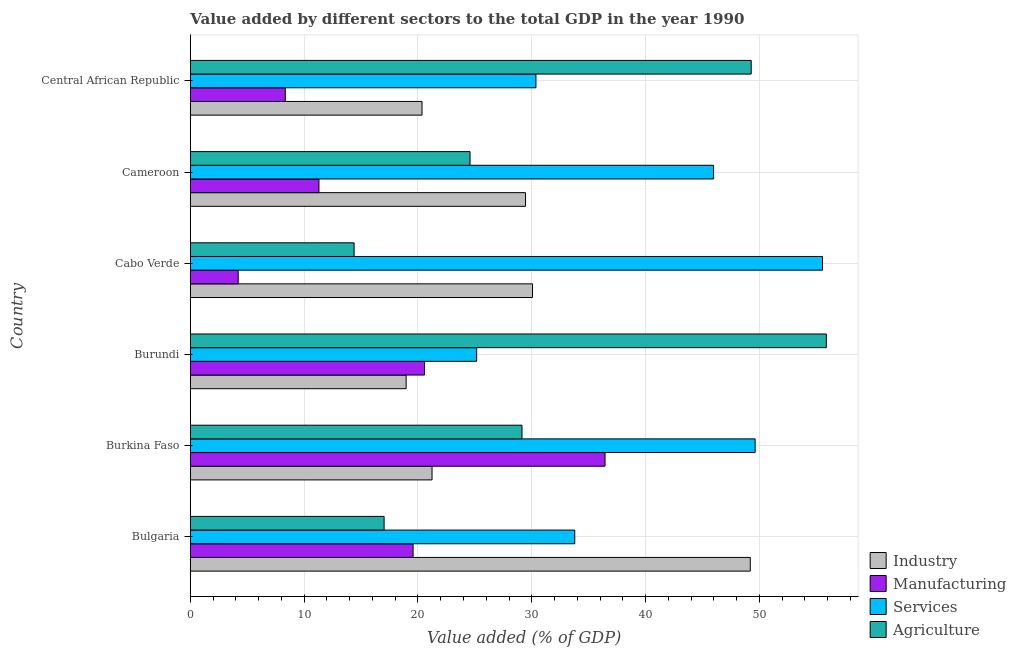How many groups of bars are there?
Offer a terse response. 6. Are the number of bars per tick equal to the number of legend labels?
Provide a short and direct response. Yes. How many bars are there on the 5th tick from the bottom?
Keep it short and to the point. 4. What is the label of the 4th group of bars from the top?
Provide a short and direct response. Burundi. In how many cases, is the number of bars for a given country not equal to the number of legend labels?
Provide a short and direct response. 0. What is the value added by agricultural sector in Bulgaria?
Your answer should be very brief. 17.03. Across all countries, what is the maximum value added by manufacturing sector?
Make the answer very short. 36.44. Across all countries, what is the minimum value added by manufacturing sector?
Your response must be concise. 4.21. In which country was the value added by industrial sector maximum?
Offer a very short reply. Bulgaria. In which country was the value added by agricultural sector minimum?
Your answer should be compact. Cabo Verde. What is the total value added by industrial sector in the graph?
Make the answer very short. 169.27. What is the difference between the value added by manufacturing sector in Burkina Faso and that in Central African Republic?
Ensure brevity in your answer.  28.09. What is the difference between the value added by agricultural sector in Cameroon and the value added by manufacturing sector in Burkina Faso?
Your answer should be very brief. -11.86. What is the average value added by agricultural sector per country?
Offer a terse response. 31.71. What is the difference between the value added by industrial sector and value added by manufacturing sector in Bulgaria?
Provide a succinct answer. 29.62. What is the ratio of the value added by agricultural sector in Burundi to that in Cameroon?
Your answer should be compact. 2.27. What is the difference between the highest and the second highest value added by services sector?
Provide a short and direct response. 5.92. What is the difference between the highest and the lowest value added by agricultural sector?
Offer a very short reply. 41.49. In how many countries, is the value added by manufacturing sector greater than the average value added by manufacturing sector taken over all countries?
Offer a terse response. 3. Is the sum of the value added by industrial sector in Cabo Verde and Central African Republic greater than the maximum value added by manufacturing sector across all countries?
Keep it short and to the point. Yes. What does the 1st bar from the top in Central African Republic represents?
Provide a succinct answer. Agriculture. What does the 1st bar from the bottom in Bulgaria represents?
Your response must be concise. Industry. Is it the case that in every country, the sum of the value added by industrial sector and value added by manufacturing sector is greater than the value added by services sector?
Your answer should be compact. No. Are all the bars in the graph horizontal?
Provide a short and direct response. Yes. How many countries are there in the graph?
Give a very brief answer. 6. How are the legend labels stacked?
Your answer should be compact. Vertical. What is the title of the graph?
Keep it short and to the point. Value added by different sectors to the total GDP in the year 1990. What is the label or title of the X-axis?
Provide a succinct answer. Value added (% of GDP). What is the label or title of the Y-axis?
Provide a succinct answer. Country. What is the Value added (% of GDP) in Industry in Bulgaria?
Your response must be concise. 49.2. What is the Value added (% of GDP) of Manufacturing in Bulgaria?
Provide a succinct answer. 19.57. What is the Value added (% of GDP) in Services in Bulgaria?
Provide a short and direct response. 33.78. What is the Value added (% of GDP) of Agriculture in Bulgaria?
Offer a very short reply. 17.03. What is the Value added (% of GDP) in Industry in Burkina Faso?
Make the answer very short. 21.24. What is the Value added (% of GDP) in Manufacturing in Burkina Faso?
Offer a terse response. 36.44. What is the Value added (% of GDP) in Services in Burkina Faso?
Keep it short and to the point. 49.62. What is the Value added (% of GDP) in Agriculture in Burkina Faso?
Your response must be concise. 29.14. What is the Value added (% of GDP) in Industry in Burundi?
Offer a very short reply. 18.96. What is the Value added (% of GDP) in Manufacturing in Burundi?
Your answer should be compact. 20.58. What is the Value added (% of GDP) in Services in Burundi?
Provide a succinct answer. 25.16. What is the Value added (% of GDP) in Agriculture in Burundi?
Your answer should be compact. 55.88. What is the Value added (% of GDP) in Industry in Cabo Verde?
Make the answer very short. 30.07. What is the Value added (% of GDP) of Manufacturing in Cabo Verde?
Your response must be concise. 4.21. What is the Value added (% of GDP) in Services in Cabo Verde?
Make the answer very short. 55.54. What is the Value added (% of GDP) in Agriculture in Cabo Verde?
Your answer should be compact. 14.39. What is the Value added (% of GDP) of Industry in Cameroon?
Provide a short and direct response. 29.45. What is the Value added (% of GDP) in Manufacturing in Cameroon?
Your response must be concise. 11.3. What is the Value added (% of GDP) in Services in Cameroon?
Offer a terse response. 45.97. What is the Value added (% of GDP) of Agriculture in Cameroon?
Ensure brevity in your answer.  24.58. What is the Value added (% of GDP) in Industry in Central African Republic?
Provide a succinct answer. 20.36. What is the Value added (% of GDP) in Manufacturing in Central African Republic?
Offer a terse response. 8.35. What is the Value added (% of GDP) in Services in Central African Republic?
Offer a terse response. 30.37. What is the Value added (% of GDP) in Agriculture in Central African Republic?
Offer a very short reply. 49.28. Across all countries, what is the maximum Value added (% of GDP) in Industry?
Provide a succinct answer. 49.2. Across all countries, what is the maximum Value added (% of GDP) of Manufacturing?
Your answer should be compact. 36.44. Across all countries, what is the maximum Value added (% of GDP) in Services?
Ensure brevity in your answer.  55.54. Across all countries, what is the maximum Value added (% of GDP) of Agriculture?
Make the answer very short. 55.88. Across all countries, what is the minimum Value added (% of GDP) of Industry?
Provide a short and direct response. 18.96. Across all countries, what is the minimum Value added (% of GDP) in Manufacturing?
Your answer should be compact. 4.21. Across all countries, what is the minimum Value added (% of GDP) in Services?
Your answer should be very brief. 25.16. Across all countries, what is the minimum Value added (% of GDP) of Agriculture?
Give a very brief answer. 14.39. What is the total Value added (% of GDP) in Industry in the graph?
Give a very brief answer. 169.27. What is the total Value added (% of GDP) in Manufacturing in the graph?
Your response must be concise. 100.45. What is the total Value added (% of GDP) of Services in the graph?
Your answer should be compact. 240.44. What is the total Value added (% of GDP) of Agriculture in the graph?
Your answer should be compact. 190.29. What is the difference between the Value added (% of GDP) in Industry in Bulgaria and that in Burkina Faso?
Your answer should be very brief. 27.96. What is the difference between the Value added (% of GDP) of Manufacturing in Bulgaria and that in Burkina Faso?
Ensure brevity in your answer.  -16.86. What is the difference between the Value added (% of GDP) in Services in Bulgaria and that in Burkina Faso?
Your answer should be compact. -15.84. What is the difference between the Value added (% of GDP) in Agriculture in Bulgaria and that in Burkina Faso?
Ensure brevity in your answer.  -12.11. What is the difference between the Value added (% of GDP) in Industry in Bulgaria and that in Burundi?
Your answer should be compact. 30.23. What is the difference between the Value added (% of GDP) of Manufacturing in Bulgaria and that in Burundi?
Give a very brief answer. -1.01. What is the difference between the Value added (% of GDP) in Services in Bulgaria and that in Burundi?
Your response must be concise. 8.62. What is the difference between the Value added (% of GDP) in Agriculture in Bulgaria and that in Burundi?
Provide a succinct answer. -38.85. What is the difference between the Value added (% of GDP) in Industry in Bulgaria and that in Cabo Verde?
Offer a terse response. 19.13. What is the difference between the Value added (% of GDP) of Manufacturing in Bulgaria and that in Cabo Verde?
Give a very brief answer. 15.36. What is the difference between the Value added (% of GDP) of Services in Bulgaria and that in Cabo Verde?
Provide a succinct answer. -21.77. What is the difference between the Value added (% of GDP) of Agriculture in Bulgaria and that in Cabo Verde?
Keep it short and to the point. 2.64. What is the difference between the Value added (% of GDP) in Industry in Bulgaria and that in Cameroon?
Ensure brevity in your answer.  19.75. What is the difference between the Value added (% of GDP) in Manufacturing in Bulgaria and that in Cameroon?
Your answer should be very brief. 8.27. What is the difference between the Value added (% of GDP) in Services in Bulgaria and that in Cameroon?
Provide a succinct answer. -12.2. What is the difference between the Value added (% of GDP) in Agriculture in Bulgaria and that in Cameroon?
Provide a short and direct response. -7.55. What is the difference between the Value added (% of GDP) of Industry in Bulgaria and that in Central African Republic?
Provide a succinct answer. 28.84. What is the difference between the Value added (% of GDP) of Manufacturing in Bulgaria and that in Central African Republic?
Keep it short and to the point. 11.23. What is the difference between the Value added (% of GDP) in Services in Bulgaria and that in Central African Republic?
Provide a succinct answer. 3.41. What is the difference between the Value added (% of GDP) of Agriculture in Bulgaria and that in Central African Republic?
Your answer should be very brief. -32.25. What is the difference between the Value added (% of GDP) in Industry in Burkina Faso and that in Burundi?
Your answer should be very brief. 2.27. What is the difference between the Value added (% of GDP) of Manufacturing in Burkina Faso and that in Burundi?
Your response must be concise. 15.86. What is the difference between the Value added (% of GDP) in Services in Burkina Faso and that in Burundi?
Make the answer very short. 24.46. What is the difference between the Value added (% of GDP) in Agriculture in Burkina Faso and that in Burundi?
Ensure brevity in your answer.  -26.74. What is the difference between the Value added (% of GDP) of Industry in Burkina Faso and that in Cabo Verde?
Make the answer very short. -8.83. What is the difference between the Value added (% of GDP) of Manufacturing in Burkina Faso and that in Cabo Verde?
Offer a very short reply. 32.23. What is the difference between the Value added (% of GDP) of Services in Burkina Faso and that in Cabo Verde?
Your answer should be very brief. -5.92. What is the difference between the Value added (% of GDP) of Agriculture in Burkina Faso and that in Cabo Verde?
Offer a terse response. 14.75. What is the difference between the Value added (% of GDP) in Industry in Burkina Faso and that in Cameroon?
Keep it short and to the point. -8.21. What is the difference between the Value added (% of GDP) in Manufacturing in Burkina Faso and that in Cameroon?
Provide a succinct answer. 25.13. What is the difference between the Value added (% of GDP) in Services in Burkina Faso and that in Cameroon?
Your response must be concise. 3.65. What is the difference between the Value added (% of GDP) of Agriculture in Burkina Faso and that in Cameroon?
Ensure brevity in your answer.  4.57. What is the difference between the Value added (% of GDP) of Industry in Burkina Faso and that in Central African Republic?
Provide a succinct answer. 0.88. What is the difference between the Value added (% of GDP) of Manufacturing in Burkina Faso and that in Central African Republic?
Your answer should be compact. 28.09. What is the difference between the Value added (% of GDP) in Services in Burkina Faso and that in Central African Republic?
Keep it short and to the point. 19.26. What is the difference between the Value added (% of GDP) in Agriculture in Burkina Faso and that in Central African Republic?
Provide a short and direct response. -20.13. What is the difference between the Value added (% of GDP) in Industry in Burundi and that in Cabo Verde?
Keep it short and to the point. -11.1. What is the difference between the Value added (% of GDP) of Manufacturing in Burundi and that in Cabo Verde?
Provide a short and direct response. 16.37. What is the difference between the Value added (% of GDP) in Services in Burundi and that in Cabo Verde?
Offer a terse response. -30.39. What is the difference between the Value added (% of GDP) in Agriculture in Burundi and that in Cabo Verde?
Your answer should be compact. 41.49. What is the difference between the Value added (% of GDP) in Industry in Burundi and that in Cameroon?
Your answer should be compact. -10.49. What is the difference between the Value added (% of GDP) of Manufacturing in Burundi and that in Cameroon?
Keep it short and to the point. 9.28. What is the difference between the Value added (% of GDP) in Services in Burundi and that in Cameroon?
Make the answer very short. -20.82. What is the difference between the Value added (% of GDP) of Agriculture in Burundi and that in Cameroon?
Provide a succinct answer. 31.3. What is the difference between the Value added (% of GDP) of Industry in Burundi and that in Central African Republic?
Give a very brief answer. -1.39. What is the difference between the Value added (% of GDP) in Manufacturing in Burundi and that in Central African Republic?
Ensure brevity in your answer.  12.23. What is the difference between the Value added (% of GDP) in Services in Burundi and that in Central African Republic?
Make the answer very short. -5.21. What is the difference between the Value added (% of GDP) in Agriculture in Burundi and that in Central African Republic?
Make the answer very short. 6.6. What is the difference between the Value added (% of GDP) in Industry in Cabo Verde and that in Cameroon?
Provide a short and direct response. 0.61. What is the difference between the Value added (% of GDP) in Manufacturing in Cabo Verde and that in Cameroon?
Ensure brevity in your answer.  -7.09. What is the difference between the Value added (% of GDP) in Services in Cabo Verde and that in Cameroon?
Your answer should be very brief. 9.57. What is the difference between the Value added (% of GDP) of Agriculture in Cabo Verde and that in Cameroon?
Provide a succinct answer. -10.18. What is the difference between the Value added (% of GDP) in Industry in Cabo Verde and that in Central African Republic?
Ensure brevity in your answer.  9.71. What is the difference between the Value added (% of GDP) in Manufacturing in Cabo Verde and that in Central African Republic?
Ensure brevity in your answer.  -4.14. What is the difference between the Value added (% of GDP) of Services in Cabo Verde and that in Central African Republic?
Keep it short and to the point. 25.18. What is the difference between the Value added (% of GDP) of Agriculture in Cabo Verde and that in Central African Republic?
Your answer should be very brief. -34.89. What is the difference between the Value added (% of GDP) of Industry in Cameroon and that in Central African Republic?
Your answer should be very brief. 9.09. What is the difference between the Value added (% of GDP) in Manufacturing in Cameroon and that in Central African Republic?
Make the answer very short. 2.96. What is the difference between the Value added (% of GDP) of Services in Cameroon and that in Central African Republic?
Keep it short and to the point. 15.61. What is the difference between the Value added (% of GDP) in Agriculture in Cameroon and that in Central African Republic?
Offer a terse response. -24.7. What is the difference between the Value added (% of GDP) of Industry in Bulgaria and the Value added (% of GDP) of Manufacturing in Burkina Faso?
Provide a succinct answer. 12.76. What is the difference between the Value added (% of GDP) in Industry in Bulgaria and the Value added (% of GDP) in Services in Burkina Faso?
Provide a short and direct response. -0.42. What is the difference between the Value added (% of GDP) of Industry in Bulgaria and the Value added (% of GDP) of Agriculture in Burkina Faso?
Your response must be concise. 20.06. What is the difference between the Value added (% of GDP) of Manufacturing in Bulgaria and the Value added (% of GDP) of Services in Burkina Faso?
Provide a succinct answer. -30.05. What is the difference between the Value added (% of GDP) of Manufacturing in Bulgaria and the Value added (% of GDP) of Agriculture in Burkina Faso?
Offer a very short reply. -9.57. What is the difference between the Value added (% of GDP) in Services in Bulgaria and the Value added (% of GDP) in Agriculture in Burkina Faso?
Provide a short and direct response. 4.64. What is the difference between the Value added (% of GDP) in Industry in Bulgaria and the Value added (% of GDP) in Manufacturing in Burundi?
Keep it short and to the point. 28.62. What is the difference between the Value added (% of GDP) in Industry in Bulgaria and the Value added (% of GDP) in Services in Burundi?
Offer a very short reply. 24.04. What is the difference between the Value added (% of GDP) in Industry in Bulgaria and the Value added (% of GDP) in Agriculture in Burundi?
Offer a terse response. -6.68. What is the difference between the Value added (% of GDP) of Manufacturing in Bulgaria and the Value added (% of GDP) of Services in Burundi?
Your response must be concise. -5.59. What is the difference between the Value added (% of GDP) in Manufacturing in Bulgaria and the Value added (% of GDP) in Agriculture in Burundi?
Provide a short and direct response. -36.31. What is the difference between the Value added (% of GDP) of Services in Bulgaria and the Value added (% of GDP) of Agriculture in Burundi?
Give a very brief answer. -22.1. What is the difference between the Value added (% of GDP) in Industry in Bulgaria and the Value added (% of GDP) in Manufacturing in Cabo Verde?
Make the answer very short. 44.99. What is the difference between the Value added (% of GDP) in Industry in Bulgaria and the Value added (% of GDP) in Services in Cabo Verde?
Offer a terse response. -6.35. What is the difference between the Value added (% of GDP) in Industry in Bulgaria and the Value added (% of GDP) in Agriculture in Cabo Verde?
Give a very brief answer. 34.81. What is the difference between the Value added (% of GDP) of Manufacturing in Bulgaria and the Value added (% of GDP) of Services in Cabo Verde?
Provide a succinct answer. -35.97. What is the difference between the Value added (% of GDP) of Manufacturing in Bulgaria and the Value added (% of GDP) of Agriculture in Cabo Verde?
Provide a short and direct response. 5.18. What is the difference between the Value added (% of GDP) of Services in Bulgaria and the Value added (% of GDP) of Agriculture in Cabo Verde?
Your response must be concise. 19.39. What is the difference between the Value added (% of GDP) of Industry in Bulgaria and the Value added (% of GDP) of Manufacturing in Cameroon?
Your response must be concise. 37.89. What is the difference between the Value added (% of GDP) in Industry in Bulgaria and the Value added (% of GDP) in Services in Cameroon?
Provide a succinct answer. 3.22. What is the difference between the Value added (% of GDP) in Industry in Bulgaria and the Value added (% of GDP) in Agriculture in Cameroon?
Your answer should be compact. 24.62. What is the difference between the Value added (% of GDP) in Manufacturing in Bulgaria and the Value added (% of GDP) in Services in Cameroon?
Your response must be concise. -26.4. What is the difference between the Value added (% of GDP) in Manufacturing in Bulgaria and the Value added (% of GDP) in Agriculture in Cameroon?
Give a very brief answer. -5. What is the difference between the Value added (% of GDP) of Services in Bulgaria and the Value added (% of GDP) of Agriculture in Cameroon?
Provide a succinct answer. 9.2. What is the difference between the Value added (% of GDP) in Industry in Bulgaria and the Value added (% of GDP) in Manufacturing in Central African Republic?
Offer a terse response. 40.85. What is the difference between the Value added (% of GDP) of Industry in Bulgaria and the Value added (% of GDP) of Services in Central African Republic?
Provide a short and direct response. 18.83. What is the difference between the Value added (% of GDP) of Industry in Bulgaria and the Value added (% of GDP) of Agriculture in Central African Republic?
Make the answer very short. -0.08. What is the difference between the Value added (% of GDP) in Manufacturing in Bulgaria and the Value added (% of GDP) in Services in Central African Republic?
Make the answer very short. -10.79. What is the difference between the Value added (% of GDP) in Manufacturing in Bulgaria and the Value added (% of GDP) in Agriculture in Central African Republic?
Ensure brevity in your answer.  -29.7. What is the difference between the Value added (% of GDP) in Services in Bulgaria and the Value added (% of GDP) in Agriculture in Central African Republic?
Your response must be concise. -15.5. What is the difference between the Value added (% of GDP) of Industry in Burkina Faso and the Value added (% of GDP) of Manufacturing in Burundi?
Provide a short and direct response. 0.66. What is the difference between the Value added (% of GDP) in Industry in Burkina Faso and the Value added (% of GDP) in Services in Burundi?
Keep it short and to the point. -3.92. What is the difference between the Value added (% of GDP) of Industry in Burkina Faso and the Value added (% of GDP) of Agriculture in Burundi?
Provide a succinct answer. -34.64. What is the difference between the Value added (% of GDP) of Manufacturing in Burkina Faso and the Value added (% of GDP) of Services in Burundi?
Ensure brevity in your answer.  11.28. What is the difference between the Value added (% of GDP) of Manufacturing in Burkina Faso and the Value added (% of GDP) of Agriculture in Burundi?
Offer a terse response. -19.44. What is the difference between the Value added (% of GDP) in Services in Burkina Faso and the Value added (% of GDP) in Agriculture in Burundi?
Your response must be concise. -6.26. What is the difference between the Value added (% of GDP) in Industry in Burkina Faso and the Value added (% of GDP) in Manufacturing in Cabo Verde?
Give a very brief answer. 17.03. What is the difference between the Value added (% of GDP) in Industry in Burkina Faso and the Value added (% of GDP) in Services in Cabo Verde?
Your answer should be very brief. -34.31. What is the difference between the Value added (% of GDP) of Industry in Burkina Faso and the Value added (% of GDP) of Agriculture in Cabo Verde?
Offer a terse response. 6.85. What is the difference between the Value added (% of GDP) of Manufacturing in Burkina Faso and the Value added (% of GDP) of Services in Cabo Verde?
Your answer should be very brief. -19.11. What is the difference between the Value added (% of GDP) of Manufacturing in Burkina Faso and the Value added (% of GDP) of Agriculture in Cabo Verde?
Ensure brevity in your answer.  22.05. What is the difference between the Value added (% of GDP) in Services in Burkina Faso and the Value added (% of GDP) in Agriculture in Cabo Verde?
Provide a succinct answer. 35.23. What is the difference between the Value added (% of GDP) in Industry in Burkina Faso and the Value added (% of GDP) in Manufacturing in Cameroon?
Keep it short and to the point. 9.93. What is the difference between the Value added (% of GDP) of Industry in Burkina Faso and the Value added (% of GDP) of Services in Cameroon?
Offer a terse response. -24.74. What is the difference between the Value added (% of GDP) of Industry in Burkina Faso and the Value added (% of GDP) of Agriculture in Cameroon?
Your answer should be very brief. -3.34. What is the difference between the Value added (% of GDP) of Manufacturing in Burkina Faso and the Value added (% of GDP) of Services in Cameroon?
Provide a short and direct response. -9.54. What is the difference between the Value added (% of GDP) in Manufacturing in Burkina Faso and the Value added (% of GDP) in Agriculture in Cameroon?
Give a very brief answer. 11.86. What is the difference between the Value added (% of GDP) in Services in Burkina Faso and the Value added (% of GDP) in Agriculture in Cameroon?
Your answer should be very brief. 25.05. What is the difference between the Value added (% of GDP) of Industry in Burkina Faso and the Value added (% of GDP) of Manufacturing in Central African Republic?
Your answer should be compact. 12.89. What is the difference between the Value added (% of GDP) in Industry in Burkina Faso and the Value added (% of GDP) in Services in Central African Republic?
Your answer should be compact. -9.13. What is the difference between the Value added (% of GDP) in Industry in Burkina Faso and the Value added (% of GDP) in Agriculture in Central African Republic?
Offer a very short reply. -28.04. What is the difference between the Value added (% of GDP) in Manufacturing in Burkina Faso and the Value added (% of GDP) in Services in Central African Republic?
Your answer should be very brief. 6.07. What is the difference between the Value added (% of GDP) of Manufacturing in Burkina Faso and the Value added (% of GDP) of Agriculture in Central African Republic?
Give a very brief answer. -12.84. What is the difference between the Value added (% of GDP) of Services in Burkina Faso and the Value added (% of GDP) of Agriculture in Central African Republic?
Your response must be concise. 0.34. What is the difference between the Value added (% of GDP) in Industry in Burundi and the Value added (% of GDP) in Manufacturing in Cabo Verde?
Your response must be concise. 14.75. What is the difference between the Value added (% of GDP) of Industry in Burundi and the Value added (% of GDP) of Services in Cabo Verde?
Provide a short and direct response. -36.58. What is the difference between the Value added (% of GDP) in Industry in Burundi and the Value added (% of GDP) in Agriculture in Cabo Verde?
Offer a terse response. 4.57. What is the difference between the Value added (% of GDP) in Manufacturing in Burundi and the Value added (% of GDP) in Services in Cabo Verde?
Offer a very short reply. -34.96. What is the difference between the Value added (% of GDP) in Manufacturing in Burundi and the Value added (% of GDP) in Agriculture in Cabo Verde?
Offer a terse response. 6.19. What is the difference between the Value added (% of GDP) in Services in Burundi and the Value added (% of GDP) in Agriculture in Cabo Verde?
Offer a very short reply. 10.77. What is the difference between the Value added (% of GDP) in Industry in Burundi and the Value added (% of GDP) in Manufacturing in Cameroon?
Offer a terse response. 7.66. What is the difference between the Value added (% of GDP) of Industry in Burundi and the Value added (% of GDP) of Services in Cameroon?
Your response must be concise. -27.01. What is the difference between the Value added (% of GDP) of Industry in Burundi and the Value added (% of GDP) of Agriculture in Cameroon?
Provide a succinct answer. -5.61. What is the difference between the Value added (% of GDP) in Manufacturing in Burundi and the Value added (% of GDP) in Services in Cameroon?
Provide a short and direct response. -25.39. What is the difference between the Value added (% of GDP) in Manufacturing in Burundi and the Value added (% of GDP) in Agriculture in Cameroon?
Ensure brevity in your answer.  -4. What is the difference between the Value added (% of GDP) of Services in Burundi and the Value added (% of GDP) of Agriculture in Cameroon?
Ensure brevity in your answer.  0.58. What is the difference between the Value added (% of GDP) of Industry in Burundi and the Value added (% of GDP) of Manufacturing in Central African Republic?
Give a very brief answer. 10.62. What is the difference between the Value added (% of GDP) in Industry in Burundi and the Value added (% of GDP) in Services in Central African Republic?
Make the answer very short. -11.4. What is the difference between the Value added (% of GDP) of Industry in Burundi and the Value added (% of GDP) of Agriculture in Central African Republic?
Offer a terse response. -30.31. What is the difference between the Value added (% of GDP) in Manufacturing in Burundi and the Value added (% of GDP) in Services in Central African Republic?
Offer a very short reply. -9.79. What is the difference between the Value added (% of GDP) of Manufacturing in Burundi and the Value added (% of GDP) of Agriculture in Central African Republic?
Your answer should be very brief. -28.7. What is the difference between the Value added (% of GDP) of Services in Burundi and the Value added (% of GDP) of Agriculture in Central African Republic?
Offer a very short reply. -24.12. What is the difference between the Value added (% of GDP) in Industry in Cabo Verde and the Value added (% of GDP) in Manufacturing in Cameroon?
Ensure brevity in your answer.  18.76. What is the difference between the Value added (% of GDP) in Industry in Cabo Verde and the Value added (% of GDP) in Services in Cameroon?
Provide a short and direct response. -15.91. What is the difference between the Value added (% of GDP) in Industry in Cabo Verde and the Value added (% of GDP) in Agriculture in Cameroon?
Offer a very short reply. 5.49. What is the difference between the Value added (% of GDP) of Manufacturing in Cabo Verde and the Value added (% of GDP) of Services in Cameroon?
Give a very brief answer. -41.77. What is the difference between the Value added (% of GDP) of Manufacturing in Cabo Verde and the Value added (% of GDP) of Agriculture in Cameroon?
Your answer should be compact. -20.37. What is the difference between the Value added (% of GDP) in Services in Cabo Verde and the Value added (% of GDP) in Agriculture in Cameroon?
Your response must be concise. 30.97. What is the difference between the Value added (% of GDP) of Industry in Cabo Verde and the Value added (% of GDP) of Manufacturing in Central African Republic?
Make the answer very short. 21.72. What is the difference between the Value added (% of GDP) of Industry in Cabo Verde and the Value added (% of GDP) of Services in Central African Republic?
Offer a terse response. -0.3. What is the difference between the Value added (% of GDP) in Industry in Cabo Verde and the Value added (% of GDP) in Agriculture in Central African Republic?
Offer a very short reply. -19.21. What is the difference between the Value added (% of GDP) in Manufacturing in Cabo Verde and the Value added (% of GDP) in Services in Central African Republic?
Your answer should be very brief. -26.16. What is the difference between the Value added (% of GDP) in Manufacturing in Cabo Verde and the Value added (% of GDP) in Agriculture in Central African Republic?
Your response must be concise. -45.07. What is the difference between the Value added (% of GDP) in Services in Cabo Verde and the Value added (% of GDP) in Agriculture in Central African Republic?
Give a very brief answer. 6.27. What is the difference between the Value added (% of GDP) in Industry in Cameroon and the Value added (% of GDP) in Manufacturing in Central African Republic?
Provide a short and direct response. 21.1. What is the difference between the Value added (% of GDP) in Industry in Cameroon and the Value added (% of GDP) in Services in Central African Republic?
Give a very brief answer. -0.92. What is the difference between the Value added (% of GDP) of Industry in Cameroon and the Value added (% of GDP) of Agriculture in Central African Republic?
Make the answer very short. -19.83. What is the difference between the Value added (% of GDP) in Manufacturing in Cameroon and the Value added (% of GDP) in Services in Central African Republic?
Make the answer very short. -19.06. What is the difference between the Value added (% of GDP) in Manufacturing in Cameroon and the Value added (% of GDP) in Agriculture in Central African Republic?
Offer a terse response. -37.97. What is the difference between the Value added (% of GDP) of Services in Cameroon and the Value added (% of GDP) of Agriculture in Central African Republic?
Give a very brief answer. -3.3. What is the average Value added (% of GDP) of Industry per country?
Give a very brief answer. 28.21. What is the average Value added (% of GDP) in Manufacturing per country?
Provide a succinct answer. 16.74. What is the average Value added (% of GDP) of Services per country?
Your answer should be very brief. 40.07. What is the average Value added (% of GDP) in Agriculture per country?
Offer a terse response. 31.71. What is the difference between the Value added (% of GDP) of Industry and Value added (% of GDP) of Manufacturing in Bulgaria?
Your response must be concise. 29.62. What is the difference between the Value added (% of GDP) of Industry and Value added (% of GDP) of Services in Bulgaria?
Give a very brief answer. 15.42. What is the difference between the Value added (% of GDP) in Industry and Value added (% of GDP) in Agriculture in Bulgaria?
Provide a succinct answer. 32.17. What is the difference between the Value added (% of GDP) in Manufacturing and Value added (% of GDP) in Services in Bulgaria?
Provide a short and direct response. -14.2. What is the difference between the Value added (% of GDP) in Manufacturing and Value added (% of GDP) in Agriculture in Bulgaria?
Provide a succinct answer. 2.55. What is the difference between the Value added (% of GDP) of Services and Value added (% of GDP) of Agriculture in Bulgaria?
Your answer should be very brief. 16.75. What is the difference between the Value added (% of GDP) of Industry and Value added (% of GDP) of Manufacturing in Burkina Faso?
Give a very brief answer. -15.2. What is the difference between the Value added (% of GDP) of Industry and Value added (% of GDP) of Services in Burkina Faso?
Your answer should be very brief. -28.38. What is the difference between the Value added (% of GDP) of Industry and Value added (% of GDP) of Agriculture in Burkina Faso?
Make the answer very short. -7.9. What is the difference between the Value added (% of GDP) of Manufacturing and Value added (% of GDP) of Services in Burkina Faso?
Provide a short and direct response. -13.19. What is the difference between the Value added (% of GDP) in Manufacturing and Value added (% of GDP) in Agriculture in Burkina Faso?
Provide a short and direct response. 7.29. What is the difference between the Value added (% of GDP) of Services and Value added (% of GDP) of Agriculture in Burkina Faso?
Your answer should be very brief. 20.48. What is the difference between the Value added (% of GDP) in Industry and Value added (% of GDP) in Manufacturing in Burundi?
Provide a succinct answer. -1.62. What is the difference between the Value added (% of GDP) of Industry and Value added (% of GDP) of Services in Burundi?
Offer a terse response. -6.19. What is the difference between the Value added (% of GDP) of Industry and Value added (% of GDP) of Agriculture in Burundi?
Your answer should be compact. -36.92. What is the difference between the Value added (% of GDP) of Manufacturing and Value added (% of GDP) of Services in Burundi?
Offer a very short reply. -4.58. What is the difference between the Value added (% of GDP) of Manufacturing and Value added (% of GDP) of Agriculture in Burundi?
Your answer should be compact. -35.3. What is the difference between the Value added (% of GDP) in Services and Value added (% of GDP) in Agriculture in Burundi?
Your response must be concise. -30.72. What is the difference between the Value added (% of GDP) of Industry and Value added (% of GDP) of Manufacturing in Cabo Verde?
Provide a succinct answer. 25.86. What is the difference between the Value added (% of GDP) of Industry and Value added (% of GDP) of Services in Cabo Verde?
Provide a short and direct response. -25.48. What is the difference between the Value added (% of GDP) in Industry and Value added (% of GDP) in Agriculture in Cabo Verde?
Offer a terse response. 15.67. What is the difference between the Value added (% of GDP) in Manufacturing and Value added (% of GDP) in Services in Cabo Verde?
Ensure brevity in your answer.  -51.34. What is the difference between the Value added (% of GDP) in Manufacturing and Value added (% of GDP) in Agriculture in Cabo Verde?
Your response must be concise. -10.18. What is the difference between the Value added (% of GDP) in Services and Value added (% of GDP) in Agriculture in Cabo Verde?
Your answer should be very brief. 41.15. What is the difference between the Value added (% of GDP) in Industry and Value added (% of GDP) in Manufacturing in Cameroon?
Give a very brief answer. 18.15. What is the difference between the Value added (% of GDP) in Industry and Value added (% of GDP) in Services in Cameroon?
Provide a succinct answer. -16.52. What is the difference between the Value added (% of GDP) in Industry and Value added (% of GDP) in Agriculture in Cameroon?
Keep it short and to the point. 4.88. What is the difference between the Value added (% of GDP) of Manufacturing and Value added (% of GDP) of Services in Cameroon?
Your answer should be compact. -34.67. What is the difference between the Value added (% of GDP) in Manufacturing and Value added (% of GDP) in Agriculture in Cameroon?
Make the answer very short. -13.27. What is the difference between the Value added (% of GDP) of Services and Value added (% of GDP) of Agriculture in Cameroon?
Offer a very short reply. 21.4. What is the difference between the Value added (% of GDP) in Industry and Value added (% of GDP) in Manufacturing in Central African Republic?
Offer a very short reply. 12.01. What is the difference between the Value added (% of GDP) in Industry and Value added (% of GDP) in Services in Central African Republic?
Provide a short and direct response. -10.01. What is the difference between the Value added (% of GDP) in Industry and Value added (% of GDP) in Agriculture in Central African Republic?
Your response must be concise. -28.92. What is the difference between the Value added (% of GDP) in Manufacturing and Value added (% of GDP) in Services in Central African Republic?
Your response must be concise. -22.02. What is the difference between the Value added (% of GDP) of Manufacturing and Value added (% of GDP) of Agriculture in Central African Republic?
Provide a succinct answer. -40.93. What is the difference between the Value added (% of GDP) of Services and Value added (% of GDP) of Agriculture in Central African Republic?
Make the answer very short. -18.91. What is the ratio of the Value added (% of GDP) in Industry in Bulgaria to that in Burkina Faso?
Provide a succinct answer. 2.32. What is the ratio of the Value added (% of GDP) in Manufacturing in Bulgaria to that in Burkina Faso?
Give a very brief answer. 0.54. What is the ratio of the Value added (% of GDP) of Services in Bulgaria to that in Burkina Faso?
Offer a very short reply. 0.68. What is the ratio of the Value added (% of GDP) in Agriculture in Bulgaria to that in Burkina Faso?
Give a very brief answer. 0.58. What is the ratio of the Value added (% of GDP) of Industry in Bulgaria to that in Burundi?
Offer a terse response. 2.59. What is the ratio of the Value added (% of GDP) of Manufacturing in Bulgaria to that in Burundi?
Make the answer very short. 0.95. What is the ratio of the Value added (% of GDP) of Services in Bulgaria to that in Burundi?
Your answer should be compact. 1.34. What is the ratio of the Value added (% of GDP) of Agriculture in Bulgaria to that in Burundi?
Provide a short and direct response. 0.3. What is the ratio of the Value added (% of GDP) in Industry in Bulgaria to that in Cabo Verde?
Your answer should be compact. 1.64. What is the ratio of the Value added (% of GDP) of Manufacturing in Bulgaria to that in Cabo Verde?
Keep it short and to the point. 4.65. What is the ratio of the Value added (% of GDP) of Services in Bulgaria to that in Cabo Verde?
Keep it short and to the point. 0.61. What is the ratio of the Value added (% of GDP) of Agriculture in Bulgaria to that in Cabo Verde?
Offer a very short reply. 1.18. What is the ratio of the Value added (% of GDP) of Industry in Bulgaria to that in Cameroon?
Ensure brevity in your answer.  1.67. What is the ratio of the Value added (% of GDP) of Manufacturing in Bulgaria to that in Cameroon?
Make the answer very short. 1.73. What is the ratio of the Value added (% of GDP) of Services in Bulgaria to that in Cameroon?
Provide a short and direct response. 0.73. What is the ratio of the Value added (% of GDP) of Agriculture in Bulgaria to that in Cameroon?
Keep it short and to the point. 0.69. What is the ratio of the Value added (% of GDP) in Industry in Bulgaria to that in Central African Republic?
Provide a short and direct response. 2.42. What is the ratio of the Value added (% of GDP) of Manufacturing in Bulgaria to that in Central African Republic?
Ensure brevity in your answer.  2.35. What is the ratio of the Value added (% of GDP) in Services in Bulgaria to that in Central African Republic?
Offer a very short reply. 1.11. What is the ratio of the Value added (% of GDP) of Agriculture in Bulgaria to that in Central African Republic?
Your answer should be very brief. 0.35. What is the ratio of the Value added (% of GDP) of Industry in Burkina Faso to that in Burundi?
Keep it short and to the point. 1.12. What is the ratio of the Value added (% of GDP) of Manufacturing in Burkina Faso to that in Burundi?
Offer a very short reply. 1.77. What is the ratio of the Value added (% of GDP) in Services in Burkina Faso to that in Burundi?
Provide a succinct answer. 1.97. What is the ratio of the Value added (% of GDP) in Agriculture in Burkina Faso to that in Burundi?
Your response must be concise. 0.52. What is the ratio of the Value added (% of GDP) in Industry in Burkina Faso to that in Cabo Verde?
Provide a short and direct response. 0.71. What is the ratio of the Value added (% of GDP) in Manufacturing in Burkina Faso to that in Cabo Verde?
Offer a terse response. 8.66. What is the ratio of the Value added (% of GDP) of Services in Burkina Faso to that in Cabo Verde?
Your answer should be very brief. 0.89. What is the ratio of the Value added (% of GDP) of Agriculture in Burkina Faso to that in Cabo Verde?
Offer a terse response. 2.02. What is the ratio of the Value added (% of GDP) in Industry in Burkina Faso to that in Cameroon?
Make the answer very short. 0.72. What is the ratio of the Value added (% of GDP) in Manufacturing in Burkina Faso to that in Cameroon?
Keep it short and to the point. 3.22. What is the ratio of the Value added (% of GDP) in Services in Burkina Faso to that in Cameroon?
Give a very brief answer. 1.08. What is the ratio of the Value added (% of GDP) in Agriculture in Burkina Faso to that in Cameroon?
Offer a very short reply. 1.19. What is the ratio of the Value added (% of GDP) of Industry in Burkina Faso to that in Central African Republic?
Your answer should be compact. 1.04. What is the ratio of the Value added (% of GDP) in Manufacturing in Burkina Faso to that in Central African Republic?
Offer a very short reply. 4.37. What is the ratio of the Value added (% of GDP) in Services in Burkina Faso to that in Central African Republic?
Your response must be concise. 1.63. What is the ratio of the Value added (% of GDP) in Agriculture in Burkina Faso to that in Central African Republic?
Your answer should be very brief. 0.59. What is the ratio of the Value added (% of GDP) of Industry in Burundi to that in Cabo Verde?
Make the answer very short. 0.63. What is the ratio of the Value added (% of GDP) in Manufacturing in Burundi to that in Cabo Verde?
Your answer should be compact. 4.89. What is the ratio of the Value added (% of GDP) in Services in Burundi to that in Cabo Verde?
Make the answer very short. 0.45. What is the ratio of the Value added (% of GDP) in Agriculture in Burundi to that in Cabo Verde?
Provide a succinct answer. 3.88. What is the ratio of the Value added (% of GDP) of Industry in Burundi to that in Cameroon?
Offer a terse response. 0.64. What is the ratio of the Value added (% of GDP) in Manufacturing in Burundi to that in Cameroon?
Keep it short and to the point. 1.82. What is the ratio of the Value added (% of GDP) of Services in Burundi to that in Cameroon?
Your answer should be compact. 0.55. What is the ratio of the Value added (% of GDP) of Agriculture in Burundi to that in Cameroon?
Your answer should be very brief. 2.27. What is the ratio of the Value added (% of GDP) in Industry in Burundi to that in Central African Republic?
Your answer should be compact. 0.93. What is the ratio of the Value added (% of GDP) in Manufacturing in Burundi to that in Central African Republic?
Offer a terse response. 2.47. What is the ratio of the Value added (% of GDP) in Services in Burundi to that in Central African Republic?
Make the answer very short. 0.83. What is the ratio of the Value added (% of GDP) in Agriculture in Burundi to that in Central African Republic?
Give a very brief answer. 1.13. What is the ratio of the Value added (% of GDP) in Industry in Cabo Verde to that in Cameroon?
Keep it short and to the point. 1.02. What is the ratio of the Value added (% of GDP) in Manufacturing in Cabo Verde to that in Cameroon?
Offer a very short reply. 0.37. What is the ratio of the Value added (% of GDP) of Services in Cabo Verde to that in Cameroon?
Your answer should be very brief. 1.21. What is the ratio of the Value added (% of GDP) in Agriculture in Cabo Verde to that in Cameroon?
Your answer should be very brief. 0.59. What is the ratio of the Value added (% of GDP) in Industry in Cabo Verde to that in Central African Republic?
Make the answer very short. 1.48. What is the ratio of the Value added (% of GDP) of Manufacturing in Cabo Verde to that in Central African Republic?
Provide a short and direct response. 0.5. What is the ratio of the Value added (% of GDP) in Services in Cabo Verde to that in Central African Republic?
Your answer should be compact. 1.83. What is the ratio of the Value added (% of GDP) in Agriculture in Cabo Verde to that in Central African Republic?
Provide a succinct answer. 0.29. What is the ratio of the Value added (% of GDP) in Industry in Cameroon to that in Central African Republic?
Offer a terse response. 1.45. What is the ratio of the Value added (% of GDP) of Manufacturing in Cameroon to that in Central African Republic?
Make the answer very short. 1.35. What is the ratio of the Value added (% of GDP) of Services in Cameroon to that in Central African Republic?
Keep it short and to the point. 1.51. What is the ratio of the Value added (% of GDP) of Agriculture in Cameroon to that in Central African Republic?
Keep it short and to the point. 0.5. What is the difference between the highest and the second highest Value added (% of GDP) of Industry?
Offer a terse response. 19.13. What is the difference between the highest and the second highest Value added (% of GDP) in Manufacturing?
Offer a terse response. 15.86. What is the difference between the highest and the second highest Value added (% of GDP) in Services?
Your response must be concise. 5.92. What is the difference between the highest and the second highest Value added (% of GDP) in Agriculture?
Provide a short and direct response. 6.6. What is the difference between the highest and the lowest Value added (% of GDP) in Industry?
Offer a terse response. 30.23. What is the difference between the highest and the lowest Value added (% of GDP) in Manufacturing?
Your answer should be very brief. 32.23. What is the difference between the highest and the lowest Value added (% of GDP) in Services?
Provide a short and direct response. 30.39. What is the difference between the highest and the lowest Value added (% of GDP) in Agriculture?
Your response must be concise. 41.49. 